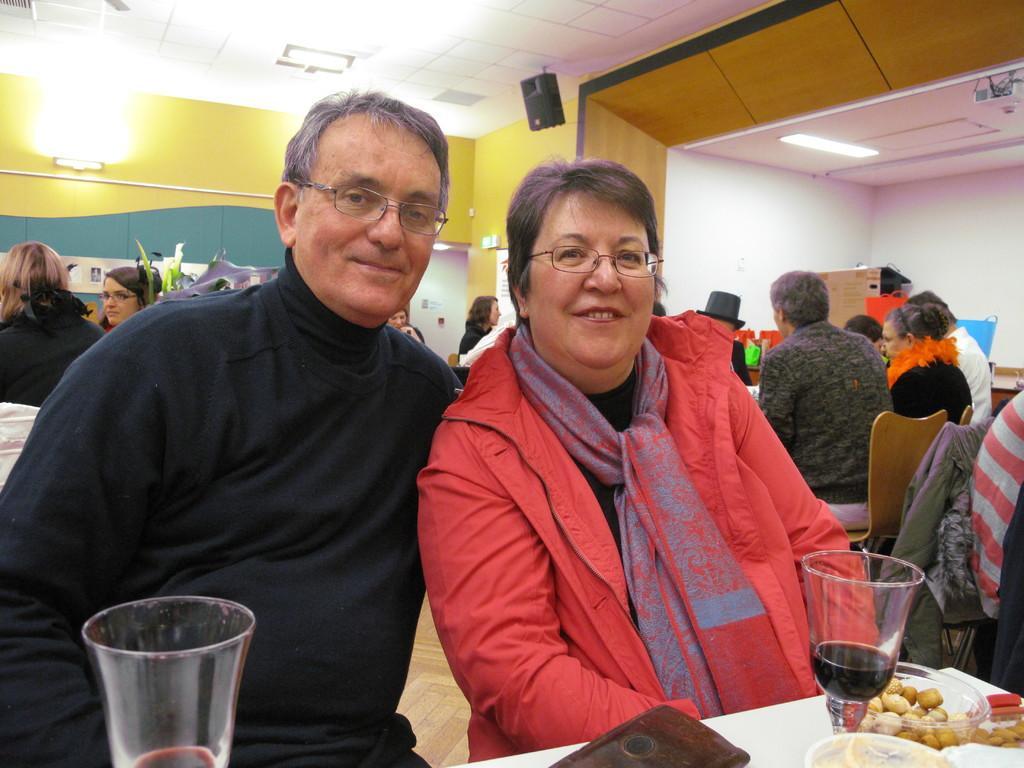Can you describe this image briefly? In this picture I can see few are sitting on the chairs and I can see couple of glasses and few bowls with some food on the table. I can see lights and a speaker to the ceiling. This picture looks like a inner view of a restaurant. 